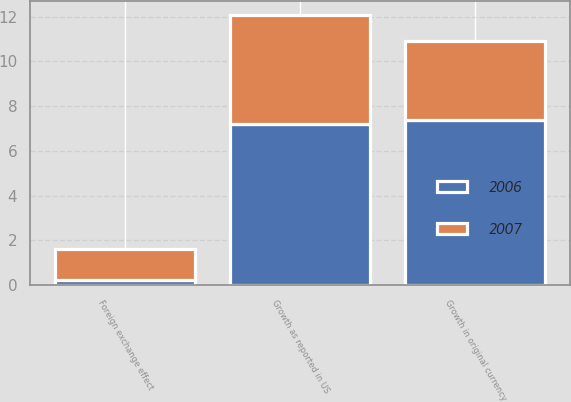<chart> <loc_0><loc_0><loc_500><loc_500><stacked_bar_chart><ecel><fcel>Growth in original currency<fcel>Foreign exchange effect<fcel>Growth as reported in US<nl><fcel>2007<fcel>3.5<fcel>1.4<fcel>4.9<nl><fcel>2006<fcel>7.4<fcel>0.2<fcel>7.2<nl></chart> 